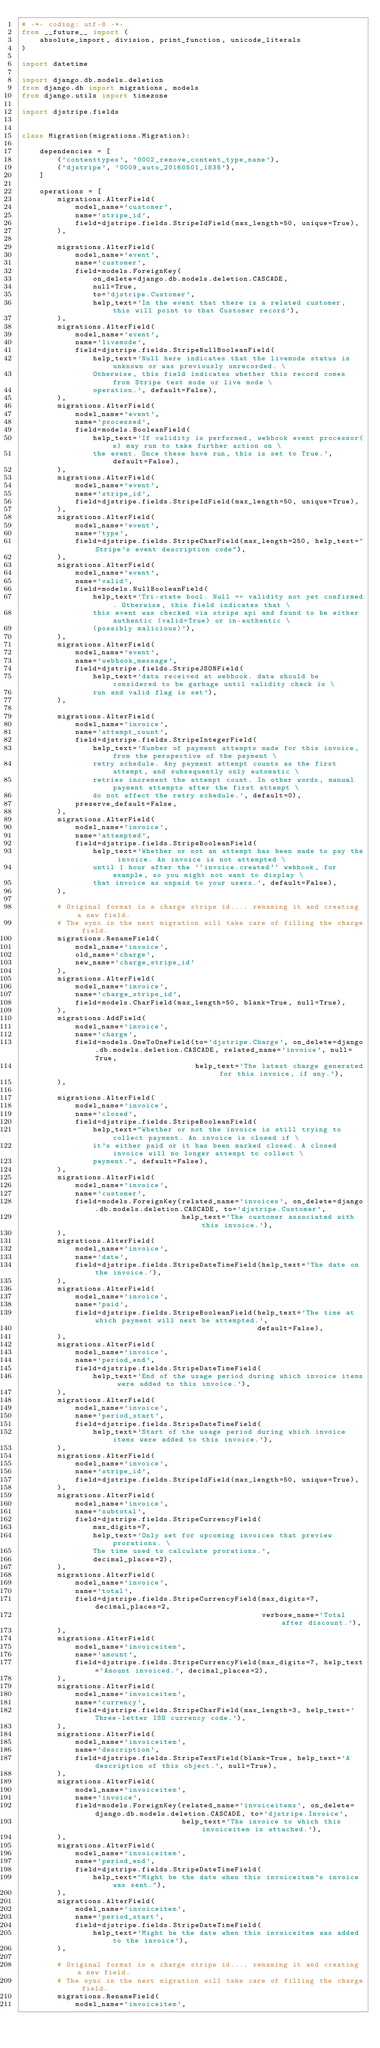<code> <loc_0><loc_0><loc_500><loc_500><_Python_># -*- coding: utf-8 -*-
from __future__ import (
    absolute_import, division, print_function, unicode_literals
)

import datetime

import django.db.models.deletion
from django.db import migrations, models
from django.utils import timezone

import djstripe.fields


class Migration(migrations.Migration):

    dependencies = [
        ('contenttypes', '0002_remove_content_type_name'),
        ('djstripe', '0009_auto_20160501_1838'),
    ]

    operations = [
        migrations.AlterField(
            model_name='customer',
            name='stripe_id',
            field=djstripe.fields.StripeIdField(max_length=50, unique=True),
        ),

        migrations.AlterField(
            model_name='event',
            name='customer',
            field=models.ForeignKey(
                on_delete=django.db.models.deletion.CASCADE,
                null=True,
                to='djstripe.Customer',
                help_text='In the event that there is a related customer, this will point to that Customer record'),
        ),
        migrations.AlterField(
            model_name='event',
            name='livemode',
            field=djstripe.fields.StripeNullBooleanField(
                help_text='Null here indicates that the livemode status is unknown or was previously unrecorded. \
                Otherwise, this field indicates whether this record comes from Stripe test mode or live mode \
                operation.', default=False),
        ),
        migrations.AlterField(
            model_name='event',
            name='processed',
            field=models.BooleanField(
                help_text='If validity is performed, webhook event processor(s) may run to take further action on \
                the event. Once these have run, this is set to True.', default=False),
        ),
        migrations.AlterField(
            model_name='event',
            name='stripe_id',
            field=djstripe.fields.StripeIdField(max_length=50, unique=True),
        ),
        migrations.AlterField(
            model_name='event',
            name='type',
            field=djstripe.fields.StripeCharField(max_length=250, help_text="Stripe's event description code"),
        ),
        migrations.AlterField(
            model_name='event',
            name='valid',
            field=models.NullBooleanField(
                help_text='Tri-state bool. Null == validity not yet confirmed. Otherwise, this field indicates that \
                this event was checked via stripe api and found to be either authentic (valid=True) or in-authentic \
                (possibly malicious)'),
        ),
        migrations.AlterField(
            model_name='event',
            name='webhook_message',
            field=djstripe.fields.StripeJSONField(
                help_text='data received at webhook. data should be considered to be garbage until validity check is \
                run and valid flag is set'),
        ),

        migrations.AlterField(
            model_name='invoice',
            name='attempt_count',
            field=djstripe.fields.StripeIntegerField(
                help_text='Number of payment attempts made for this invoice, from the perspective of the payment \
                retry schedule. Any payment attempt counts as the first attempt, and subsequently only automatic \
                retries increment the attempt count. In other words, manual payment attempts after the first attempt \
                do not affect the retry schedule.', default=0),
            preserve_default=False,
        ),
        migrations.AlterField(
            model_name='invoice',
            name='attempted',
            field=djstripe.fields.StripeBooleanField(
                help_text='Whether or not an attempt has been made to pay the invoice. An invoice is not attempted \
                until 1 hour after the ``invoice.created`` webhook, for example, so you might not want to display \
                that invoice as unpaid to your users.', default=False),
        ),

        # Original format is a charge stripe id.... renaming it and creating a new field.
        # The sync in the next migration will take care of filling the charge field.
        migrations.RenameField(
            model_name='invoice',
            old_name='charge',
            new_name='charge_stripe_id'
        ),
        migrations.AlterField(
            model_name='invoice',
            name='charge_stripe_id',
            field=models.CharField(max_length=50, blank=True, null=True),
        ),
        migrations.AddField(
            model_name='invoice',
            name='charge',
            field=models.OneToOneField(to='djstripe.Charge', on_delete=django.db.models.deletion.CASCADE, related_name='invoice', null=True,
                                       help_text='The latest charge generated for this invoice, if any.'),
        ),

        migrations.AlterField(
            model_name='invoice',
            name='closed',
            field=djstripe.fields.StripeBooleanField(
                help_text="Whether or not the invoice is still trying to collect payment. An invoice is closed if \
                it's either paid or it has been marked closed. A closed invoice will no longer attempt to collect \
                payment.", default=False),
        ),
        migrations.AlterField(
            model_name='invoice',
            name='customer',
            field=models.ForeignKey(related_name='invoices', on_delete=django.db.models.deletion.CASCADE, to='djstripe.Customer',
                                    help_text='The customer associated with this invoice.'),
        ),
        migrations.AlterField(
            model_name='invoice',
            name='date',
            field=djstripe.fields.StripeDateTimeField(help_text='The date on the invoice.'),
        ),
        migrations.AlterField(
            model_name='invoice',
            name='paid',
            field=djstripe.fields.StripeBooleanField(help_text='The time at which payment will next be attempted.',
                                                     default=False),
        ),
        migrations.AlterField(
            model_name='invoice',
            name='period_end',
            field=djstripe.fields.StripeDateTimeField(
                help_text='End of the usage period during which invoice items were added to this invoice.'),
        ),
        migrations.AlterField(
            model_name='invoice',
            name='period_start',
            field=djstripe.fields.StripeDateTimeField(
                help_text='Start of the usage period during which invoice items were added to this invoice.'),
        ),
        migrations.AlterField(
            model_name='invoice',
            name='stripe_id',
            field=djstripe.fields.StripeIdField(max_length=50, unique=True),
        ),
        migrations.AlterField(
            model_name='invoice',
            name='subtotal',
            field=djstripe.fields.StripeCurrencyField(
                max_digits=7,
                help_text='Only set for upcoming invoices that preview prorations. \
                The time used to calculate prorations.',
                decimal_places=2),
        ),
        migrations.AlterField(
            model_name='invoice',
            name='total',
            field=djstripe.fields.StripeCurrencyField(max_digits=7, decimal_places=2,
                                                      verbose_name='Total after discount.'),
        ),
        migrations.AlterField(
            model_name='invoiceitem',
            name='amount',
            field=djstripe.fields.StripeCurrencyField(max_digits=7, help_text='Amount invoiced.', decimal_places=2),
        ),
        migrations.AlterField(
            model_name='invoiceitem',
            name='currency',
            field=djstripe.fields.StripeCharField(max_length=3, help_text='Three-letter ISO currency code.'),
        ),
        migrations.AlterField(
            model_name='invoiceitem',
            name='description',
            field=djstripe.fields.StripeTextField(blank=True, help_text='A description of this object.', null=True),
        ),
        migrations.AlterField(
            model_name='invoiceitem',
            name='invoice',
            field=models.ForeignKey(related_name='invoiceitems', on_delete=django.db.models.deletion.CASCADE, to='djstripe.Invoice',
                                    help_text='The invoice to which this invoiceitem is attached.'),
        ),
        migrations.AlterField(
            model_name='invoiceitem',
            name='period_end',
            field=djstripe.fields.StripeDateTimeField(
                help_text="Might be the date when this invoiceitem's invoice was sent."),
        ),
        migrations.AlterField(
            model_name='invoiceitem',
            name='period_start',
            field=djstripe.fields.StripeDateTimeField(
                help_text='Might be the date when this invoiceitem was added to the invoice'),
        ),

        # Original format is a charge stripe id.... renaming it and creating a new field.
        # The sync in the next migration will take care of filling the charge field.
        migrations.RenameField(
            model_name='invoiceitem',</code> 